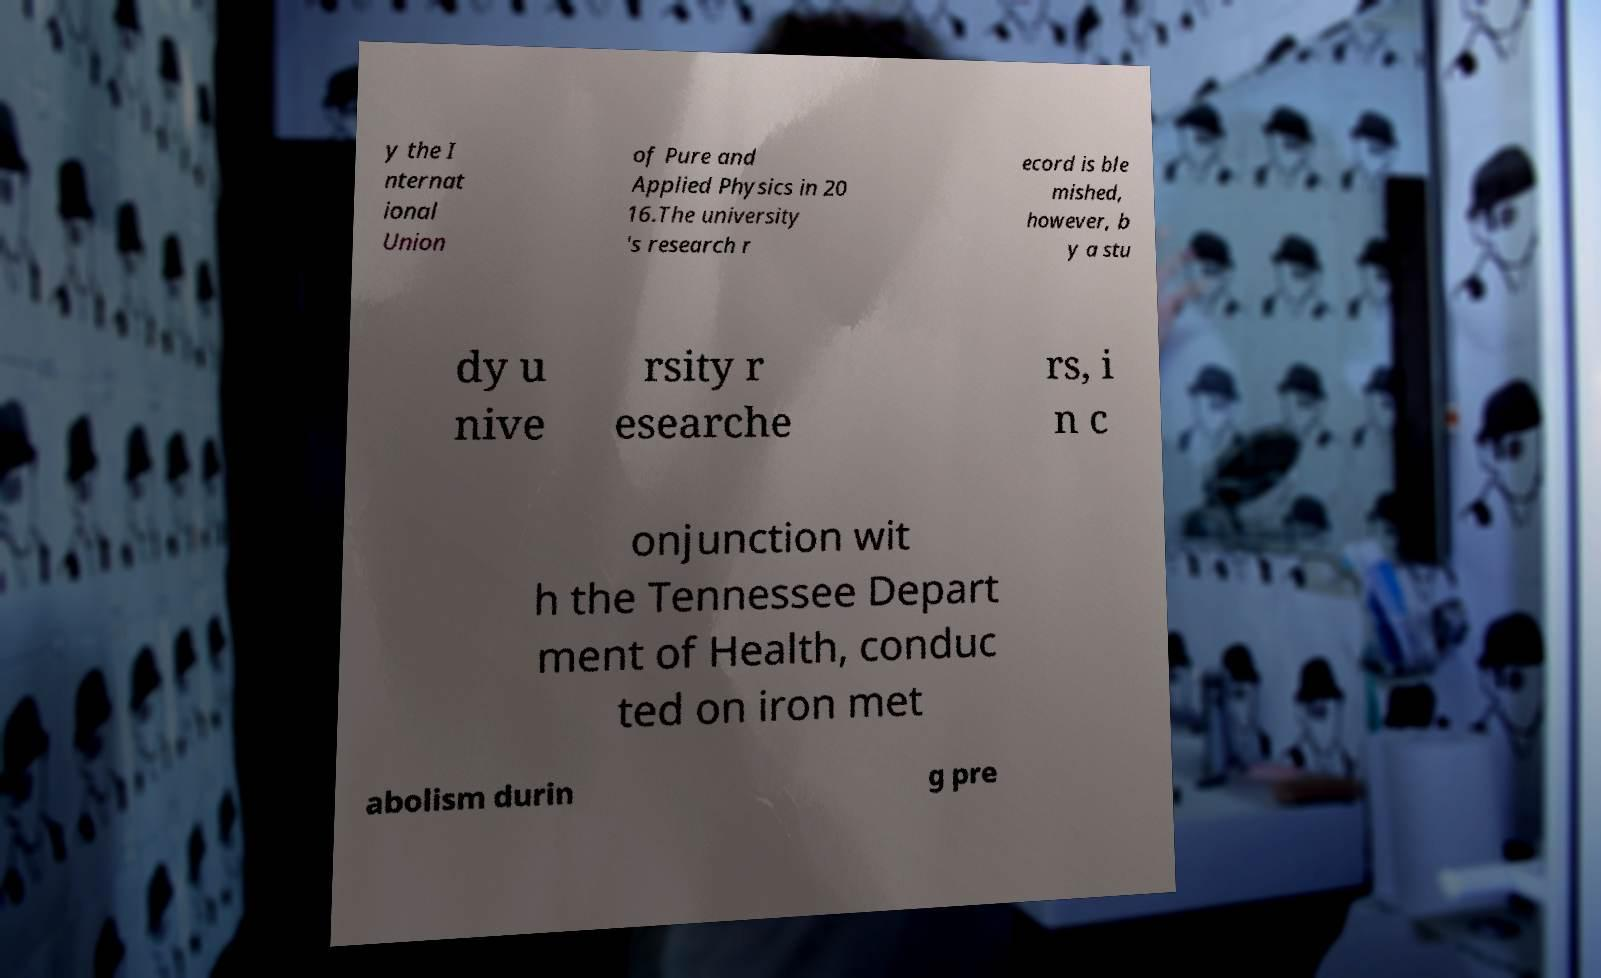For documentation purposes, I need the text within this image transcribed. Could you provide that? y the I nternat ional Union of Pure and Applied Physics in 20 16.The university 's research r ecord is ble mished, however, b y a stu dy u nive rsity r esearche rs, i n c onjunction wit h the Tennessee Depart ment of Health, conduc ted on iron met abolism durin g pre 